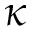Convert formula to latex. <formula><loc_0><loc_0><loc_500><loc_500>\kappa</formula> 